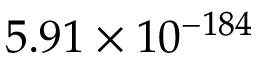<formula> <loc_0><loc_0><loc_500><loc_500>5 . 9 1 \times 1 0 ^ { - 1 8 4 }</formula> 